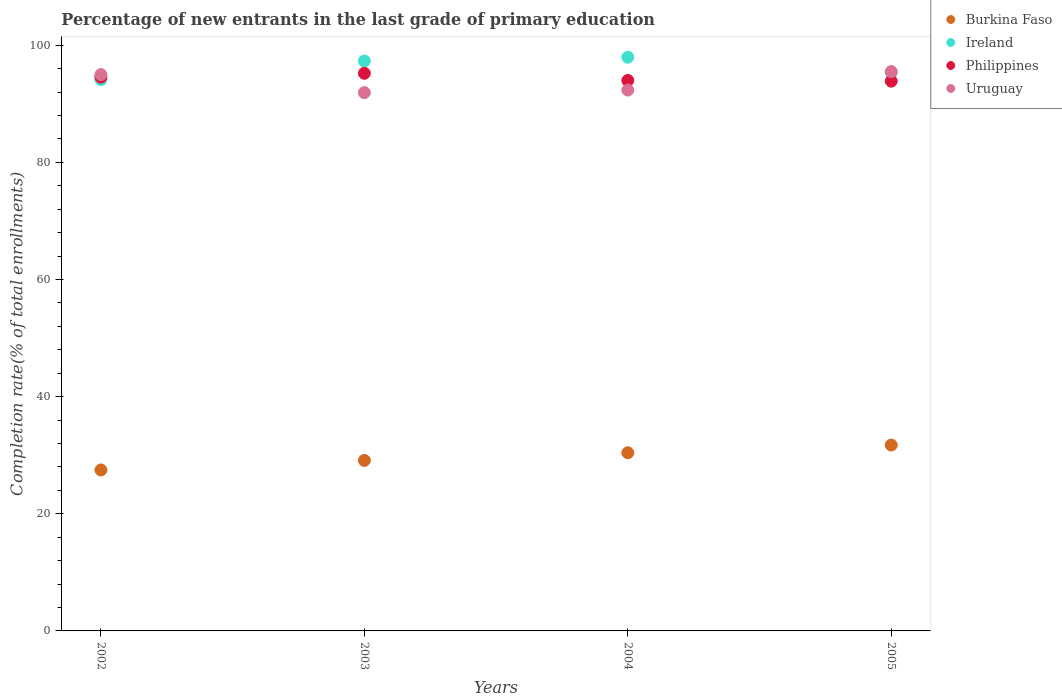How many different coloured dotlines are there?
Your response must be concise. 4. What is the percentage of new entrants in Burkina Faso in 2005?
Make the answer very short. 31.73. Across all years, what is the maximum percentage of new entrants in Philippines?
Offer a very short reply. 95.2. Across all years, what is the minimum percentage of new entrants in Burkina Faso?
Give a very brief answer. 27.48. In which year was the percentage of new entrants in Uruguay maximum?
Provide a succinct answer. 2005. In which year was the percentage of new entrants in Uruguay minimum?
Make the answer very short. 2003. What is the total percentage of new entrants in Ireland in the graph?
Offer a terse response. 384.72. What is the difference between the percentage of new entrants in Burkina Faso in 2003 and that in 2005?
Ensure brevity in your answer.  -2.63. What is the difference between the percentage of new entrants in Ireland in 2002 and the percentage of new entrants in Philippines in 2003?
Your response must be concise. -1.07. What is the average percentage of new entrants in Burkina Faso per year?
Your response must be concise. 29.69. In the year 2005, what is the difference between the percentage of new entrants in Burkina Faso and percentage of new entrants in Ireland?
Ensure brevity in your answer.  -63.61. What is the ratio of the percentage of new entrants in Ireland in 2002 to that in 2004?
Keep it short and to the point. 0.96. Is the percentage of new entrants in Ireland in 2002 less than that in 2003?
Provide a short and direct response. Yes. What is the difference between the highest and the second highest percentage of new entrants in Philippines?
Offer a terse response. 0.65. What is the difference between the highest and the lowest percentage of new entrants in Philippines?
Provide a short and direct response. 1.34. Is the sum of the percentage of new entrants in Ireland in 2003 and 2004 greater than the maximum percentage of new entrants in Burkina Faso across all years?
Ensure brevity in your answer.  Yes. Is it the case that in every year, the sum of the percentage of new entrants in Ireland and percentage of new entrants in Uruguay  is greater than the sum of percentage of new entrants in Burkina Faso and percentage of new entrants in Philippines?
Keep it short and to the point. No. Is it the case that in every year, the sum of the percentage of new entrants in Philippines and percentage of new entrants in Uruguay  is greater than the percentage of new entrants in Burkina Faso?
Your response must be concise. Yes. How many dotlines are there?
Provide a succinct answer. 4. Does the graph contain any zero values?
Offer a terse response. No. What is the title of the graph?
Your answer should be compact. Percentage of new entrants in the last grade of primary education. What is the label or title of the X-axis?
Your answer should be very brief. Years. What is the label or title of the Y-axis?
Give a very brief answer. Completion rate(% of total enrollments). What is the Completion rate(% of total enrollments) in Burkina Faso in 2002?
Keep it short and to the point. 27.48. What is the Completion rate(% of total enrollments) of Ireland in 2002?
Provide a succinct answer. 94.13. What is the Completion rate(% of total enrollments) of Philippines in 2002?
Make the answer very short. 94.55. What is the Completion rate(% of total enrollments) of Uruguay in 2002?
Keep it short and to the point. 94.98. What is the Completion rate(% of total enrollments) of Burkina Faso in 2003?
Offer a very short reply. 29.11. What is the Completion rate(% of total enrollments) of Ireland in 2003?
Your answer should be compact. 97.3. What is the Completion rate(% of total enrollments) in Philippines in 2003?
Keep it short and to the point. 95.2. What is the Completion rate(% of total enrollments) of Uruguay in 2003?
Provide a succinct answer. 91.9. What is the Completion rate(% of total enrollments) in Burkina Faso in 2004?
Your answer should be compact. 30.42. What is the Completion rate(% of total enrollments) of Ireland in 2004?
Make the answer very short. 97.95. What is the Completion rate(% of total enrollments) in Philippines in 2004?
Provide a short and direct response. 93.98. What is the Completion rate(% of total enrollments) in Uruguay in 2004?
Your response must be concise. 92.34. What is the Completion rate(% of total enrollments) of Burkina Faso in 2005?
Provide a succinct answer. 31.73. What is the Completion rate(% of total enrollments) of Ireland in 2005?
Offer a very short reply. 95.34. What is the Completion rate(% of total enrollments) in Philippines in 2005?
Ensure brevity in your answer.  93.86. What is the Completion rate(% of total enrollments) of Uruguay in 2005?
Give a very brief answer. 95.49. Across all years, what is the maximum Completion rate(% of total enrollments) of Burkina Faso?
Ensure brevity in your answer.  31.73. Across all years, what is the maximum Completion rate(% of total enrollments) of Ireland?
Your response must be concise. 97.95. Across all years, what is the maximum Completion rate(% of total enrollments) in Philippines?
Give a very brief answer. 95.2. Across all years, what is the maximum Completion rate(% of total enrollments) in Uruguay?
Keep it short and to the point. 95.49. Across all years, what is the minimum Completion rate(% of total enrollments) of Burkina Faso?
Provide a short and direct response. 27.48. Across all years, what is the minimum Completion rate(% of total enrollments) of Ireland?
Keep it short and to the point. 94.13. Across all years, what is the minimum Completion rate(% of total enrollments) of Philippines?
Provide a succinct answer. 93.86. Across all years, what is the minimum Completion rate(% of total enrollments) in Uruguay?
Provide a succinct answer. 91.9. What is the total Completion rate(% of total enrollments) of Burkina Faso in the graph?
Offer a very short reply. 118.74. What is the total Completion rate(% of total enrollments) in Ireland in the graph?
Your response must be concise. 384.72. What is the total Completion rate(% of total enrollments) of Philippines in the graph?
Your answer should be compact. 377.59. What is the total Completion rate(% of total enrollments) in Uruguay in the graph?
Your answer should be very brief. 374.7. What is the difference between the Completion rate(% of total enrollments) in Burkina Faso in 2002 and that in 2003?
Provide a succinct answer. -1.62. What is the difference between the Completion rate(% of total enrollments) in Ireland in 2002 and that in 2003?
Give a very brief answer. -3.17. What is the difference between the Completion rate(% of total enrollments) in Philippines in 2002 and that in 2003?
Provide a short and direct response. -0.65. What is the difference between the Completion rate(% of total enrollments) in Uruguay in 2002 and that in 2003?
Ensure brevity in your answer.  3.08. What is the difference between the Completion rate(% of total enrollments) in Burkina Faso in 2002 and that in 2004?
Offer a terse response. -2.94. What is the difference between the Completion rate(% of total enrollments) in Ireland in 2002 and that in 2004?
Your answer should be compact. -3.82. What is the difference between the Completion rate(% of total enrollments) in Philippines in 2002 and that in 2004?
Keep it short and to the point. 0.57. What is the difference between the Completion rate(% of total enrollments) in Uruguay in 2002 and that in 2004?
Make the answer very short. 2.64. What is the difference between the Completion rate(% of total enrollments) in Burkina Faso in 2002 and that in 2005?
Your answer should be compact. -4.25. What is the difference between the Completion rate(% of total enrollments) in Ireland in 2002 and that in 2005?
Make the answer very short. -1.21. What is the difference between the Completion rate(% of total enrollments) in Philippines in 2002 and that in 2005?
Offer a terse response. 0.69. What is the difference between the Completion rate(% of total enrollments) in Uruguay in 2002 and that in 2005?
Your answer should be very brief. -0.51. What is the difference between the Completion rate(% of total enrollments) in Burkina Faso in 2003 and that in 2004?
Your answer should be very brief. -1.31. What is the difference between the Completion rate(% of total enrollments) of Ireland in 2003 and that in 2004?
Provide a short and direct response. -0.64. What is the difference between the Completion rate(% of total enrollments) in Philippines in 2003 and that in 2004?
Give a very brief answer. 1.22. What is the difference between the Completion rate(% of total enrollments) of Uruguay in 2003 and that in 2004?
Your answer should be very brief. -0.44. What is the difference between the Completion rate(% of total enrollments) of Burkina Faso in 2003 and that in 2005?
Offer a very short reply. -2.63. What is the difference between the Completion rate(% of total enrollments) of Ireland in 2003 and that in 2005?
Your answer should be very brief. 1.96. What is the difference between the Completion rate(% of total enrollments) in Philippines in 2003 and that in 2005?
Keep it short and to the point. 1.34. What is the difference between the Completion rate(% of total enrollments) in Uruguay in 2003 and that in 2005?
Keep it short and to the point. -3.6. What is the difference between the Completion rate(% of total enrollments) in Burkina Faso in 2004 and that in 2005?
Provide a succinct answer. -1.31. What is the difference between the Completion rate(% of total enrollments) of Ireland in 2004 and that in 2005?
Provide a short and direct response. 2.61. What is the difference between the Completion rate(% of total enrollments) in Philippines in 2004 and that in 2005?
Your answer should be very brief. 0.12. What is the difference between the Completion rate(% of total enrollments) in Uruguay in 2004 and that in 2005?
Your answer should be very brief. -3.15. What is the difference between the Completion rate(% of total enrollments) in Burkina Faso in 2002 and the Completion rate(% of total enrollments) in Ireland in 2003?
Keep it short and to the point. -69.82. What is the difference between the Completion rate(% of total enrollments) of Burkina Faso in 2002 and the Completion rate(% of total enrollments) of Philippines in 2003?
Keep it short and to the point. -67.72. What is the difference between the Completion rate(% of total enrollments) in Burkina Faso in 2002 and the Completion rate(% of total enrollments) in Uruguay in 2003?
Offer a very short reply. -64.41. What is the difference between the Completion rate(% of total enrollments) of Ireland in 2002 and the Completion rate(% of total enrollments) of Philippines in 2003?
Keep it short and to the point. -1.07. What is the difference between the Completion rate(% of total enrollments) in Ireland in 2002 and the Completion rate(% of total enrollments) in Uruguay in 2003?
Offer a terse response. 2.23. What is the difference between the Completion rate(% of total enrollments) of Philippines in 2002 and the Completion rate(% of total enrollments) of Uruguay in 2003?
Keep it short and to the point. 2.65. What is the difference between the Completion rate(% of total enrollments) in Burkina Faso in 2002 and the Completion rate(% of total enrollments) in Ireland in 2004?
Give a very brief answer. -70.46. What is the difference between the Completion rate(% of total enrollments) in Burkina Faso in 2002 and the Completion rate(% of total enrollments) in Philippines in 2004?
Make the answer very short. -66.5. What is the difference between the Completion rate(% of total enrollments) in Burkina Faso in 2002 and the Completion rate(% of total enrollments) in Uruguay in 2004?
Make the answer very short. -64.86. What is the difference between the Completion rate(% of total enrollments) of Ireland in 2002 and the Completion rate(% of total enrollments) of Philippines in 2004?
Keep it short and to the point. 0.15. What is the difference between the Completion rate(% of total enrollments) in Ireland in 2002 and the Completion rate(% of total enrollments) in Uruguay in 2004?
Give a very brief answer. 1.79. What is the difference between the Completion rate(% of total enrollments) in Philippines in 2002 and the Completion rate(% of total enrollments) in Uruguay in 2004?
Your answer should be compact. 2.21. What is the difference between the Completion rate(% of total enrollments) of Burkina Faso in 2002 and the Completion rate(% of total enrollments) of Ireland in 2005?
Your answer should be very brief. -67.86. What is the difference between the Completion rate(% of total enrollments) of Burkina Faso in 2002 and the Completion rate(% of total enrollments) of Philippines in 2005?
Keep it short and to the point. -66.38. What is the difference between the Completion rate(% of total enrollments) of Burkina Faso in 2002 and the Completion rate(% of total enrollments) of Uruguay in 2005?
Give a very brief answer. -68.01. What is the difference between the Completion rate(% of total enrollments) in Ireland in 2002 and the Completion rate(% of total enrollments) in Philippines in 2005?
Offer a terse response. 0.27. What is the difference between the Completion rate(% of total enrollments) in Ireland in 2002 and the Completion rate(% of total enrollments) in Uruguay in 2005?
Provide a succinct answer. -1.36. What is the difference between the Completion rate(% of total enrollments) in Philippines in 2002 and the Completion rate(% of total enrollments) in Uruguay in 2005?
Give a very brief answer. -0.94. What is the difference between the Completion rate(% of total enrollments) in Burkina Faso in 2003 and the Completion rate(% of total enrollments) in Ireland in 2004?
Provide a short and direct response. -68.84. What is the difference between the Completion rate(% of total enrollments) in Burkina Faso in 2003 and the Completion rate(% of total enrollments) in Philippines in 2004?
Provide a short and direct response. -64.88. What is the difference between the Completion rate(% of total enrollments) in Burkina Faso in 2003 and the Completion rate(% of total enrollments) in Uruguay in 2004?
Give a very brief answer. -63.23. What is the difference between the Completion rate(% of total enrollments) in Ireland in 2003 and the Completion rate(% of total enrollments) in Philippines in 2004?
Offer a very short reply. 3.32. What is the difference between the Completion rate(% of total enrollments) in Ireland in 2003 and the Completion rate(% of total enrollments) in Uruguay in 2004?
Ensure brevity in your answer.  4.96. What is the difference between the Completion rate(% of total enrollments) of Philippines in 2003 and the Completion rate(% of total enrollments) of Uruguay in 2004?
Offer a very short reply. 2.86. What is the difference between the Completion rate(% of total enrollments) of Burkina Faso in 2003 and the Completion rate(% of total enrollments) of Ireland in 2005?
Provide a succinct answer. -66.23. What is the difference between the Completion rate(% of total enrollments) in Burkina Faso in 2003 and the Completion rate(% of total enrollments) in Philippines in 2005?
Your answer should be compact. -64.75. What is the difference between the Completion rate(% of total enrollments) of Burkina Faso in 2003 and the Completion rate(% of total enrollments) of Uruguay in 2005?
Offer a very short reply. -66.39. What is the difference between the Completion rate(% of total enrollments) in Ireland in 2003 and the Completion rate(% of total enrollments) in Philippines in 2005?
Make the answer very short. 3.44. What is the difference between the Completion rate(% of total enrollments) in Ireland in 2003 and the Completion rate(% of total enrollments) in Uruguay in 2005?
Keep it short and to the point. 1.81. What is the difference between the Completion rate(% of total enrollments) in Philippines in 2003 and the Completion rate(% of total enrollments) in Uruguay in 2005?
Offer a terse response. -0.29. What is the difference between the Completion rate(% of total enrollments) of Burkina Faso in 2004 and the Completion rate(% of total enrollments) of Ireland in 2005?
Ensure brevity in your answer.  -64.92. What is the difference between the Completion rate(% of total enrollments) in Burkina Faso in 2004 and the Completion rate(% of total enrollments) in Philippines in 2005?
Make the answer very short. -63.44. What is the difference between the Completion rate(% of total enrollments) in Burkina Faso in 2004 and the Completion rate(% of total enrollments) in Uruguay in 2005?
Your answer should be very brief. -65.07. What is the difference between the Completion rate(% of total enrollments) of Ireland in 2004 and the Completion rate(% of total enrollments) of Philippines in 2005?
Make the answer very short. 4.09. What is the difference between the Completion rate(% of total enrollments) of Ireland in 2004 and the Completion rate(% of total enrollments) of Uruguay in 2005?
Offer a terse response. 2.45. What is the difference between the Completion rate(% of total enrollments) of Philippines in 2004 and the Completion rate(% of total enrollments) of Uruguay in 2005?
Offer a very short reply. -1.51. What is the average Completion rate(% of total enrollments) of Burkina Faso per year?
Give a very brief answer. 29.69. What is the average Completion rate(% of total enrollments) of Ireland per year?
Offer a very short reply. 96.18. What is the average Completion rate(% of total enrollments) in Philippines per year?
Offer a terse response. 94.4. What is the average Completion rate(% of total enrollments) of Uruguay per year?
Provide a short and direct response. 93.68. In the year 2002, what is the difference between the Completion rate(% of total enrollments) in Burkina Faso and Completion rate(% of total enrollments) in Ireland?
Give a very brief answer. -66.65. In the year 2002, what is the difference between the Completion rate(% of total enrollments) of Burkina Faso and Completion rate(% of total enrollments) of Philippines?
Offer a terse response. -67.07. In the year 2002, what is the difference between the Completion rate(% of total enrollments) in Burkina Faso and Completion rate(% of total enrollments) in Uruguay?
Give a very brief answer. -67.49. In the year 2002, what is the difference between the Completion rate(% of total enrollments) of Ireland and Completion rate(% of total enrollments) of Philippines?
Give a very brief answer. -0.42. In the year 2002, what is the difference between the Completion rate(% of total enrollments) in Ireland and Completion rate(% of total enrollments) in Uruguay?
Make the answer very short. -0.85. In the year 2002, what is the difference between the Completion rate(% of total enrollments) of Philippines and Completion rate(% of total enrollments) of Uruguay?
Provide a succinct answer. -0.43. In the year 2003, what is the difference between the Completion rate(% of total enrollments) in Burkina Faso and Completion rate(% of total enrollments) in Ireland?
Ensure brevity in your answer.  -68.2. In the year 2003, what is the difference between the Completion rate(% of total enrollments) of Burkina Faso and Completion rate(% of total enrollments) of Philippines?
Your answer should be compact. -66.1. In the year 2003, what is the difference between the Completion rate(% of total enrollments) of Burkina Faso and Completion rate(% of total enrollments) of Uruguay?
Provide a short and direct response. -62.79. In the year 2003, what is the difference between the Completion rate(% of total enrollments) in Ireland and Completion rate(% of total enrollments) in Philippines?
Give a very brief answer. 2.1. In the year 2003, what is the difference between the Completion rate(% of total enrollments) of Ireland and Completion rate(% of total enrollments) of Uruguay?
Offer a terse response. 5.41. In the year 2003, what is the difference between the Completion rate(% of total enrollments) in Philippines and Completion rate(% of total enrollments) in Uruguay?
Offer a terse response. 3.31. In the year 2004, what is the difference between the Completion rate(% of total enrollments) in Burkina Faso and Completion rate(% of total enrollments) in Ireland?
Give a very brief answer. -67.53. In the year 2004, what is the difference between the Completion rate(% of total enrollments) in Burkina Faso and Completion rate(% of total enrollments) in Philippines?
Offer a very short reply. -63.56. In the year 2004, what is the difference between the Completion rate(% of total enrollments) of Burkina Faso and Completion rate(% of total enrollments) of Uruguay?
Give a very brief answer. -61.92. In the year 2004, what is the difference between the Completion rate(% of total enrollments) in Ireland and Completion rate(% of total enrollments) in Philippines?
Ensure brevity in your answer.  3.96. In the year 2004, what is the difference between the Completion rate(% of total enrollments) of Ireland and Completion rate(% of total enrollments) of Uruguay?
Your answer should be very brief. 5.61. In the year 2004, what is the difference between the Completion rate(% of total enrollments) in Philippines and Completion rate(% of total enrollments) in Uruguay?
Ensure brevity in your answer.  1.64. In the year 2005, what is the difference between the Completion rate(% of total enrollments) in Burkina Faso and Completion rate(% of total enrollments) in Ireland?
Ensure brevity in your answer.  -63.61. In the year 2005, what is the difference between the Completion rate(% of total enrollments) in Burkina Faso and Completion rate(% of total enrollments) in Philippines?
Give a very brief answer. -62.13. In the year 2005, what is the difference between the Completion rate(% of total enrollments) in Burkina Faso and Completion rate(% of total enrollments) in Uruguay?
Your response must be concise. -63.76. In the year 2005, what is the difference between the Completion rate(% of total enrollments) of Ireland and Completion rate(% of total enrollments) of Philippines?
Your answer should be very brief. 1.48. In the year 2005, what is the difference between the Completion rate(% of total enrollments) in Ireland and Completion rate(% of total enrollments) in Uruguay?
Provide a succinct answer. -0.15. In the year 2005, what is the difference between the Completion rate(% of total enrollments) in Philippines and Completion rate(% of total enrollments) in Uruguay?
Ensure brevity in your answer.  -1.63. What is the ratio of the Completion rate(% of total enrollments) of Burkina Faso in 2002 to that in 2003?
Your response must be concise. 0.94. What is the ratio of the Completion rate(% of total enrollments) of Ireland in 2002 to that in 2003?
Provide a short and direct response. 0.97. What is the ratio of the Completion rate(% of total enrollments) in Philippines in 2002 to that in 2003?
Ensure brevity in your answer.  0.99. What is the ratio of the Completion rate(% of total enrollments) in Uruguay in 2002 to that in 2003?
Your answer should be very brief. 1.03. What is the ratio of the Completion rate(% of total enrollments) of Burkina Faso in 2002 to that in 2004?
Offer a very short reply. 0.9. What is the ratio of the Completion rate(% of total enrollments) in Philippines in 2002 to that in 2004?
Provide a short and direct response. 1.01. What is the ratio of the Completion rate(% of total enrollments) of Uruguay in 2002 to that in 2004?
Give a very brief answer. 1.03. What is the ratio of the Completion rate(% of total enrollments) in Burkina Faso in 2002 to that in 2005?
Keep it short and to the point. 0.87. What is the ratio of the Completion rate(% of total enrollments) of Ireland in 2002 to that in 2005?
Ensure brevity in your answer.  0.99. What is the ratio of the Completion rate(% of total enrollments) in Philippines in 2002 to that in 2005?
Keep it short and to the point. 1.01. What is the ratio of the Completion rate(% of total enrollments) of Uruguay in 2002 to that in 2005?
Give a very brief answer. 0.99. What is the ratio of the Completion rate(% of total enrollments) in Burkina Faso in 2003 to that in 2004?
Provide a succinct answer. 0.96. What is the ratio of the Completion rate(% of total enrollments) in Philippines in 2003 to that in 2004?
Offer a terse response. 1.01. What is the ratio of the Completion rate(% of total enrollments) of Burkina Faso in 2003 to that in 2005?
Your response must be concise. 0.92. What is the ratio of the Completion rate(% of total enrollments) of Ireland in 2003 to that in 2005?
Your answer should be very brief. 1.02. What is the ratio of the Completion rate(% of total enrollments) of Philippines in 2003 to that in 2005?
Ensure brevity in your answer.  1.01. What is the ratio of the Completion rate(% of total enrollments) in Uruguay in 2003 to that in 2005?
Give a very brief answer. 0.96. What is the ratio of the Completion rate(% of total enrollments) in Burkina Faso in 2004 to that in 2005?
Offer a very short reply. 0.96. What is the ratio of the Completion rate(% of total enrollments) in Ireland in 2004 to that in 2005?
Your response must be concise. 1.03. What is the ratio of the Completion rate(% of total enrollments) in Philippines in 2004 to that in 2005?
Provide a short and direct response. 1. What is the ratio of the Completion rate(% of total enrollments) of Uruguay in 2004 to that in 2005?
Provide a succinct answer. 0.97. What is the difference between the highest and the second highest Completion rate(% of total enrollments) of Burkina Faso?
Keep it short and to the point. 1.31. What is the difference between the highest and the second highest Completion rate(% of total enrollments) of Ireland?
Your response must be concise. 0.64. What is the difference between the highest and the second highest Completion rate(% of total enrollments) of Philippines?
Give a very brief answer. 0.65. What is the difference between the highest and the second highest Completion rate(% of total enrollments) in Uruguay?
Provide a succinct answer. 0.51. What is the difference between the highest and the lowest Completion rate(% of total enrollments) in Burkina Faso?
Give a very brief answer. 4.25. What is the difference between the highest and the lowest Completion rate(% of total enrollments) in Ireland?
Give a very brief answer. 3.82. What is the difference between the highest and the lowest Completion rate(% of total enrollments) in Philippines?
Your answer should be compact. 1.34. What is the difference between the highest and the lowest Completion rate(% of total enrollments) in Uruguay?
Your answer should be compact. 3.6. 